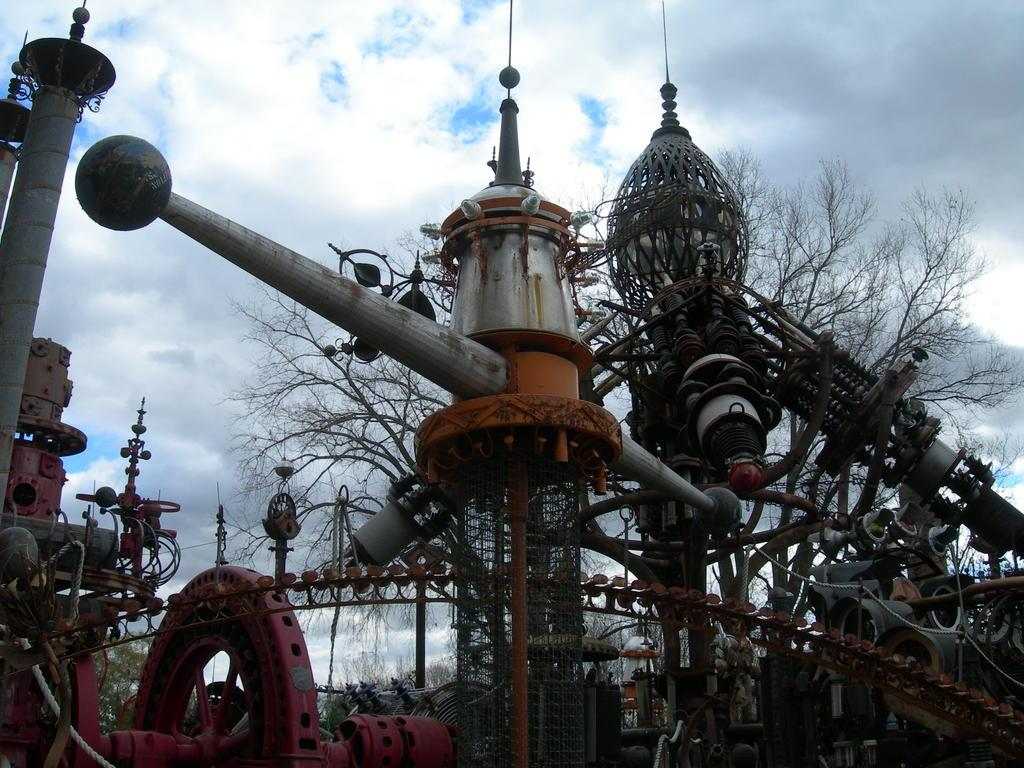What type of objects can be seen in the image? There are metal objects in the image. What can be seen in the background of the image? There are trees in the background of the image. What is visible at the top of the image? The sky is visible at the top of the image. What can be observed in the sky? Clouds are present in the sky. What color is the hair of the goldfish in the image? There is no goldfish present in the image, and therefore no hair to describe. 